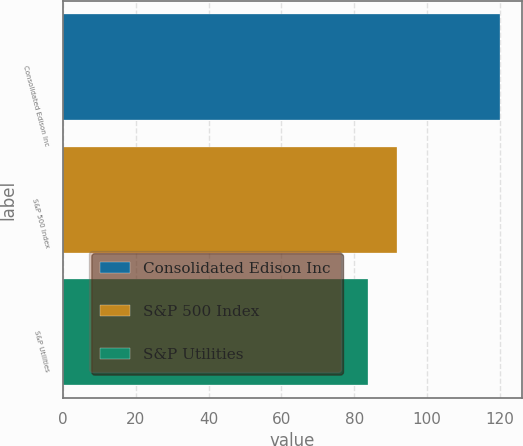Convert chart. <chart><loc_0><loc_0><loc_500><loc_500><bar_chart><fcel>Consolidated Edison Inc<fcel>S&P 500 Index<fcel>S&P Utilities<nl><fcel>119.94<fcel>91.68<fcel>83.82<nl></chart> 